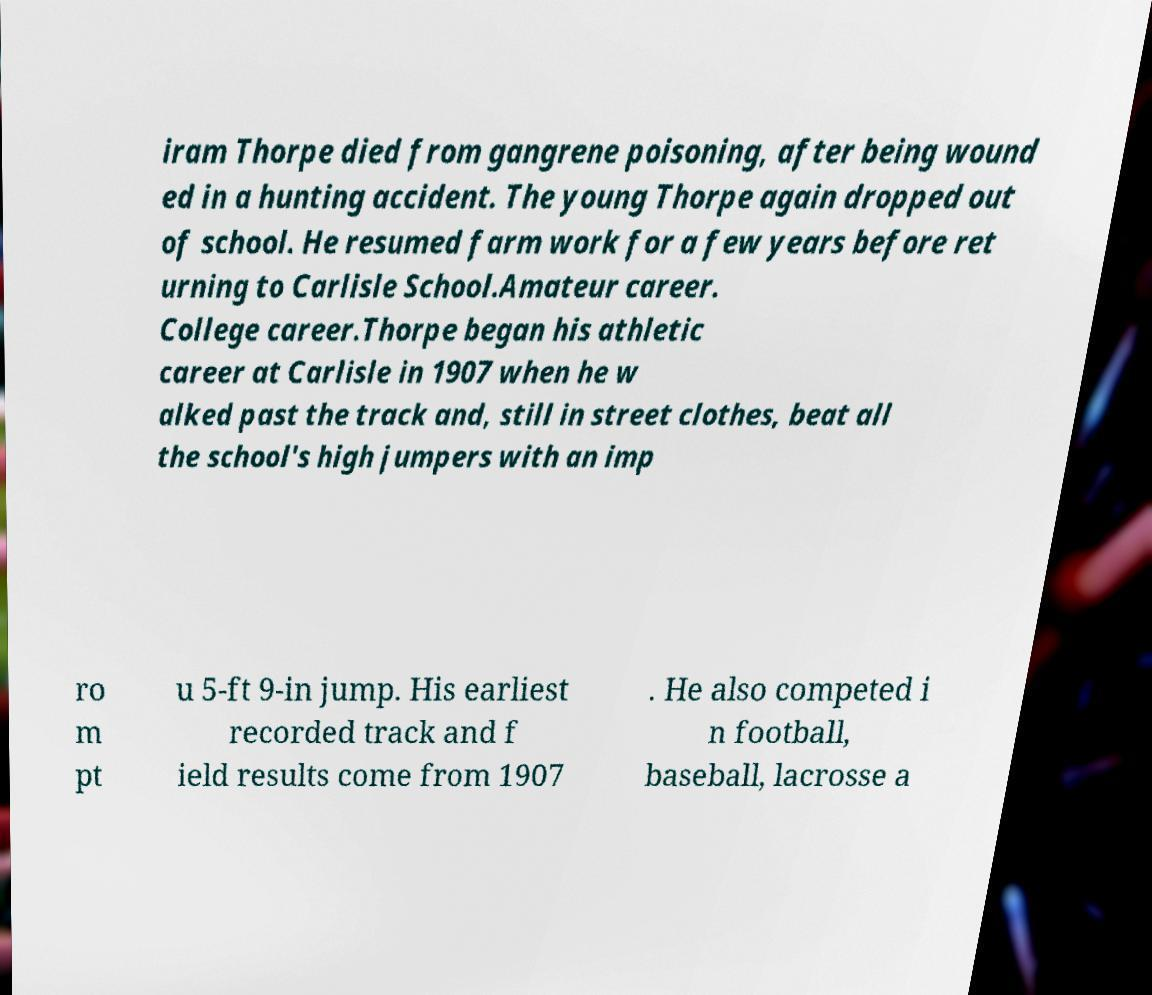Can you read and provide the text displayed in the image?This photo seems to have some interesting text. Can you extract and type it out for me? iram Thorpe died from gangrene poisoning, after being wound ed in a hunting accident. The young Thorpe again dropped out of school. He resumed farm work for a few years before ret urning to Carlisle School.Amateur career. College career.Thorpe began his athletic career at Carlisle in 1907 when he w alked past the track and, still in street clothes, beat all the school's high jumpers with an imp ro m pt u 5-ft 9-in jump. His earliest recorded track and f ield results come from 1907 . He also competed i n football, baseball, lacrosse a 